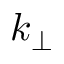Convert formula to latex. <formula><loc_0><loc_0><loc_500><loc_500>k _ { \bot }</formula> 